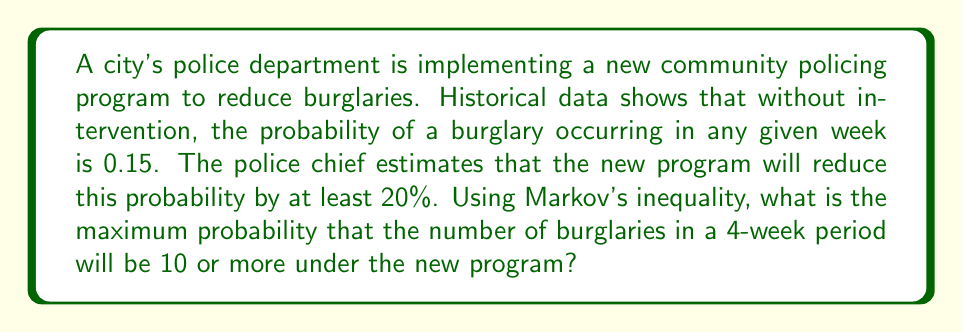Solve this math problem. Let's approach this step-by-step:

1) First, we need to calculate the new probability of a burglary occurring in a week after the 20% reduction:
   $p = 0.15 \times (1 - 0.20) = 0.15 \times 0.80 = 0.12$

2) For a 4-week period, we can model the number of burglaries as a binomial distribution with $n = 4$ weeks and $p = 0.12$.

3) The expected number of burglaries in 4 weeks is:
   $E(X) = np = 4 \times 0.12 = 0.48$

4) Markov's inequality states that for a non-negative random variable $X$ and any positive real number $a$:
   $P(X \geq a) \leq \frac{E(X)}{a}$

5) In this case, we want to find $P(X \geq 10)$, so $a = 10$:
   $P(X \geq 10) \leq \frac{E(X)}{10} = \frac{0.48}{10} = 0.048$

Therefore, the maximum probability that the number of burglaries in a 4-week period will be 10 or more is 0.048 or 4.8%.
Answer: 0.048 